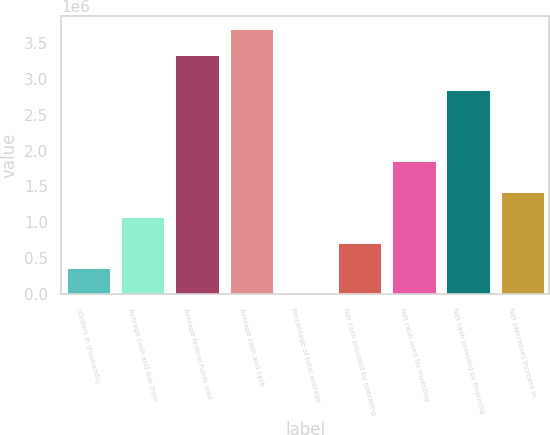Convert chart to OTSL. <chart><loc_0><loc_0><loc_500><loc_500><bar_chart><fcel>(Dollars in thousands)<fcel>Average cash and due from<fcel>Average federal funds sold<fcel>Average cash and cash<fcel>Percentage of total average<fcel>Net cash provided by operating<fcel>Net cash used for investing<fcel>Net cash provided by financing<fcel>Net (decrease) increase in<nl><fcel>357238<fcel>1.07165e+06<fcel>3.33318e+06<fcel>3.69039e+06<fcel>31.5<fcel>714444<fcel>1.85747e+06<fcel>2.84663e+06<fcel>1.42886e+06<nl></chart> 